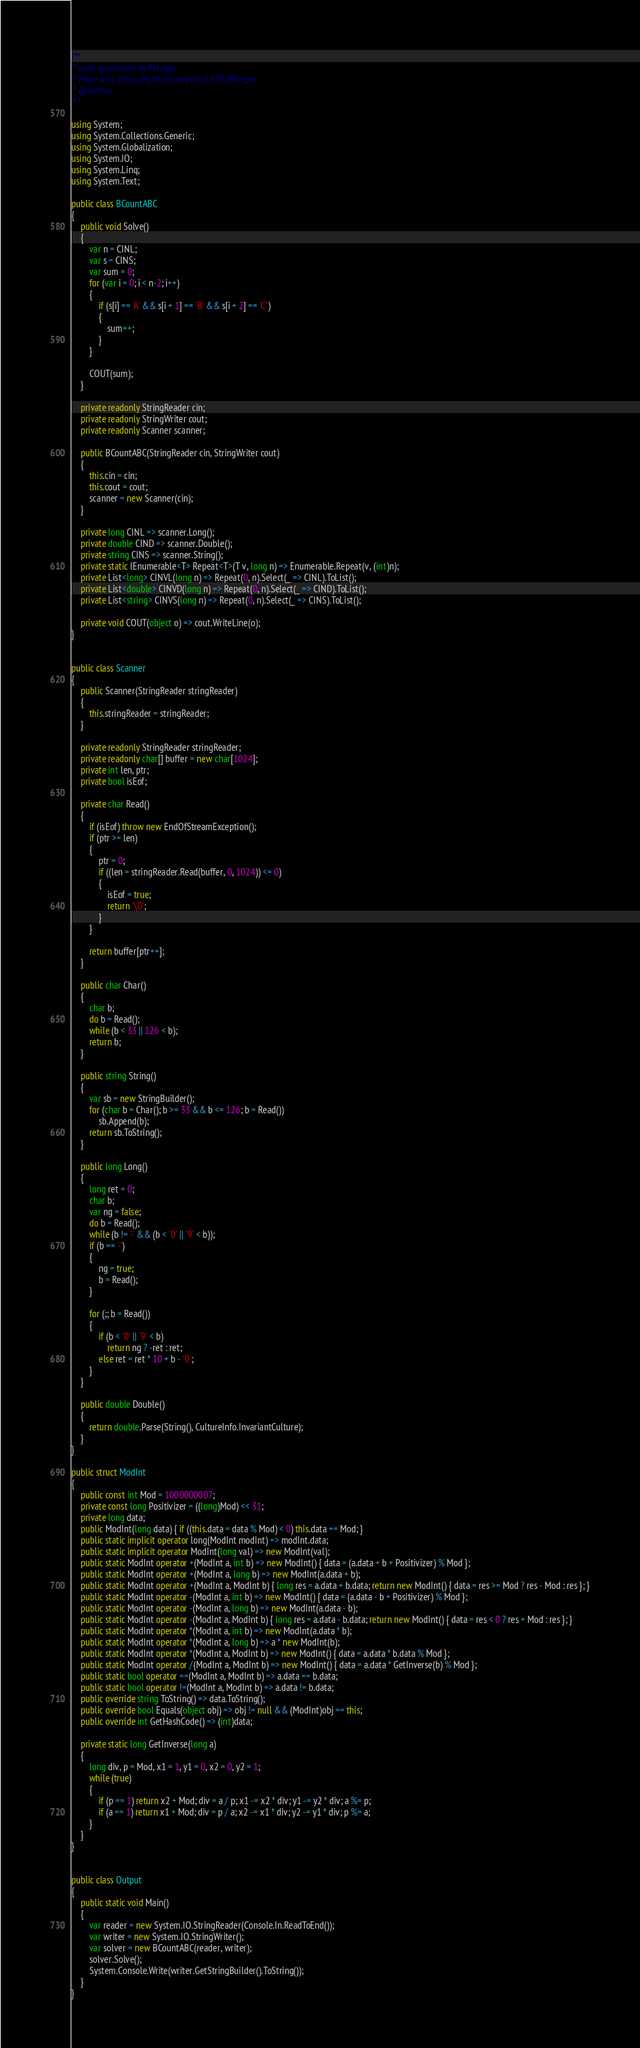Convert code to text. <code><loc_0><loc_0><loc_500><loc_500><_C#_>/**
 * code generated by RHelper
 * More info: https://github.com/mkc1370/RHelper
 * @author 
 */

using System;
using System.Collections.Generic;
using System.Globalization;
using System.IO;
using System.Linq;
using System.Text;

public class BCountABC
{
    public void Solve()
    {
        var n = CINL;
        var s = CINS;
        var sum = 0;
        for (var i = 0; i < n-2; i++)
        {
            if (s[i] == 'A' && s[i + 1] == 'B' && s[i + 2] == 'C')
            {
                sum++;
            }
        }

        COUT(sum);
    }
    
    private readonly StringReader cin;
    private readonly StringWriter cout;
    private readonly Scanner scanner;

    public BCountABC(StringReader cin, StringWriter cout)
    {
        this.cin = cin;
        this.cout = cout;
        scanner = new Scanner(cin);
    }

    private long CINL => scanner.Long();
    private double CIND => scanner.Double();
    private string CINS => scanner.String();
    private static IEnumerable<T> Repeat<T>(T v, long n) => Enumerable.Repeat(v, (int)n);
    private List<long> CINVL(long n) => Repeat(0, n).Select(_ => CINL).ToList();
    private List<double> CINVD(long n) => Repeat(0, n).Select(_ => CIND).ToList();
    private List<string> CINVS(long n) => Repeat(0, n).Select(_ => CINS).ToList();

    private void COUT(object o) => cout.WriteLine(o);
}


public class Scanner
{
    public Scanner(StringReader stringReader)
    {
        this.stringReader = stringReader;
    }

    private readonly StringReader stringReader;
    private readonly char[] buffer = new char[1024];
    private int len, ptr;
    private bool isEof;

    private char Read()
    {
        if (isEof) throw new EndOfStreamException();
        if (ptr >= len)
        {
            ptr = 0;
            if ((len = stringReader.Read(buffer, 0, 1024)) <= 0)
            {
                isEof = true;
                return '\0';
            }
        }

        return buffer[ptr++];
    }

    public char Char()
    {
        char b;
        do b = Read();
        while (b < 33 || 126 < b);
        return b;
    }

    public string String()
    {
        var sb = new StringBuilder();
        for (char b = Char(); b >= 33 && b <= 126; b = Read())
            sb.Append(b);
        return sb.ToString();
    }

    public long Long()
    {
        long ret = 0;
        char b;
        var ng = false;
        do b = Read();
        while (b != '-' && (b < '0' || '9' < b));
        if (b == '-')
        {
            ng = true;
            b = Read();
        }

        for (;; b = Read())
        {
            if (b < '0' || '9' < b)
                return ng ? -ret : ret;
            else ret = ret * 10 + b - '0';
        }
    }

    public double Double()
    {
        return double.Parse(String(), CultureInfo.InvariantCulture);
    }
}

public struct ModInt
{
    public const int Mod = 1000000007;
    private const long Positivizer = ((long)Mod) << 31;
    private long data;
    public ModInt(long data) { if ((this.data = data % Mod) < 0) this.data += Mod; }
    public static implicit operator long(ModInt modInt) => modInt.data;
    public static implicit operator ModInt(long val) => new ModInt(val);
    public static ModInt operator +(ModInt a, int b) => new ModInt() { data = (a.data + b + Positivizer) % Mod };
    public static ModInt operator +(ModInt a, long b) => new ModInt(a.data + b);
    public static ModInt operator +(ModInt a, ModInt b) { long res = a.data + b.data; return new ModInt() { data = res >= Mod ? res - Mod : res }; }
    public static ModInt operator -(ModInt a, int b) => new ModInt() { data = (a.data - b + Positivizer) % Mod };
    public static ModInt operator -(ModInt a, long b) => new ModInt(a.data - b);
    public static ModInt operator -(ModInt a, ModInt b) { long res = a.data - b.data; return new ModInt() { data = res < 0 ? res + Mod : res }; }
    public static ModInt operator *(ModInt a, int b) => new ModInt(a.data * b);
    public static ModInt operator *(ModInt a, long b) => a * new ModInt(b);
    public static ModInt operator *(ModInt a, ModInt b) => new ModInt() { data = a.data * b.data % Mod };
    public static ModInt operator /(ModInt a, ModInt b) => new ModInt() { data = a.data * GetInverse(b) % Mod };
    public static bool operator ==(ModInt a, ModInt b) => a.data == b.data;
    public static bool operator !=(ModInt a, ModInt b) => a.data != b.data;
    public override string ToString() => data.ToString();
    public override bool Equals(object obj) => obj != null && (ModInt)obj == this;
    public override int GetHashCode() => (int)data;

    private static long GetInverse(long a)
    {
        long div, p = Mod, x1 = 1, y1 = 0, x2 = 0, y2 = 1;
        while (true)
        {
            if (p == 1) return x2 + Mod; div = a / p; x1 -= x2 * div; y1 -= y2 * div; a %= p;
            if (a == 1) return x1 + Mod; div = p / a; x2 -= x1 * div; y2 -= y1 * div; p %= a;
        }
    }
}


public class Output
{
	public static void Main()
	{
		var reader = new System.IO.StringReader(Console.In.ReadToEnd());
		var writer = new System.IO.StringWriter();
		var solver = new BCountABC(reader, writer);
		solver.Solve();
		System.Console.Write(writer.GetStringBuilder().ToString());
	}
}
</code> 